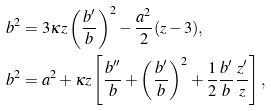<formula> <loc_0><loc_0><loc_500><loc_500>b ^ { 2 } & = 3 \kappa z \left ( \frac { b ^ { \prime } } { b } \right ) ^ { 2 } - \frac { a ^ { 2 } } { 2 } ( z - 3 ) , \\ b ^ { 2 } & = a ^ { 2 } + \kappa z \left [ \frac { b ^ { \prime \prime } } { b } + \left ( \frac { b ^ { \prime } } { b } \right ) ^ { 2 } + \frac { 1 } { 2 } \frac { b ^ { \prime } } { b } \frac { z ^ { \prime } } { z } \right ] ,</formula> 